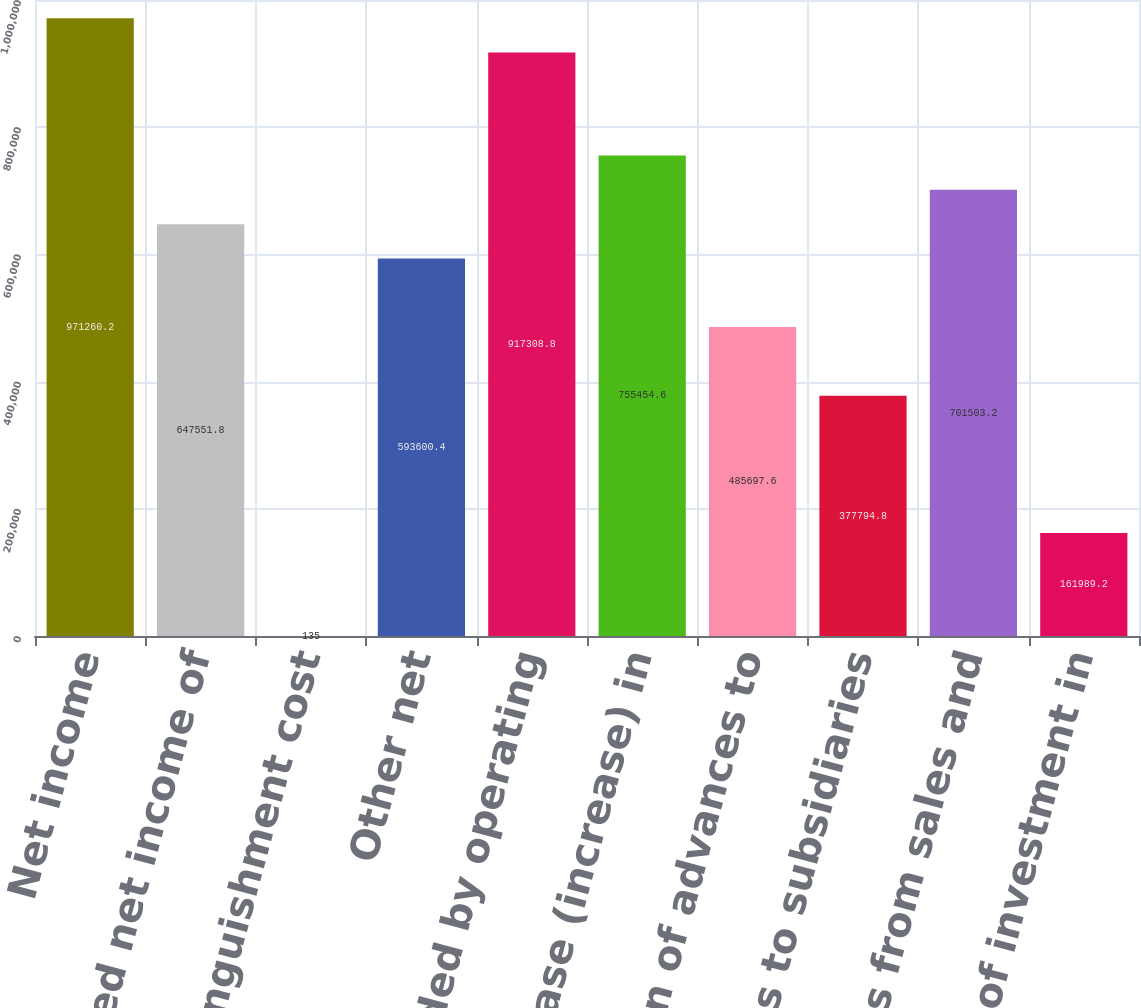Convert chart. <chart><loc_0><loc_0><loc_500><loc_500><bar_chart><fcel>Net income<fcel>Undistributed net income of<fcel>Debt extinguishment cost<fcel>Other net<fcel>Net cash provided by operating<fcel>Net decrease (increase) in<fcel>Collection of advances to<fcel>Advances to subsidiaries<fcel>Proceeds from sales and<fcel>Decrease of investment in<nl><fcel>971260<fcel>647552<fcel>135<fcel>593600<fcel>917309<fcel>755455<fcel>485698<fcel>377795<fcel>701503<fcel>161989<nl></chart> 